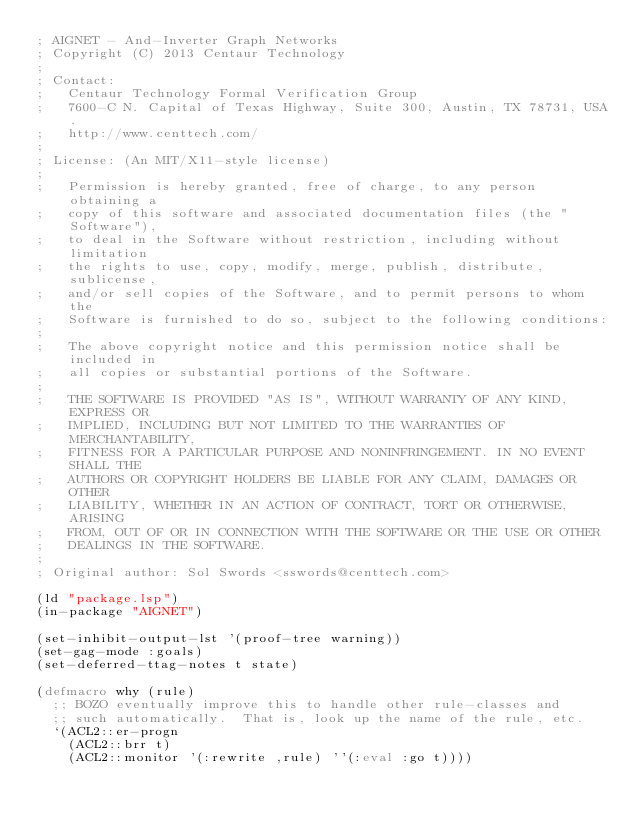<code> <loc_0><loc_0><loc_500><loc_500><_Lisp_>; AIGNET - And-Inverter Graph Networks
; Copyright (C) 2013 Centaur Technology
;
; Contact:
;   Centaur Technology Formal Verification Group
;   7600-C N. Capital of Texas Highway, Suite 300, Austin, TX 78731, USA.
;   http://www.centtech.com/
;
; License: (An MIT/X11-style license)
;
;   Permission is hereby granted, free of charge, to any person obtaining a
;   copy of this software and associated documentation files (the "Software"),
;   to deal in the Software without restriction, including without limitation
;   the rights to use, copy, modify, merge, publish, distribute, sublicense,
;   and/or sell copies of the Software, and to permit persons to whom the
;   Software is furnished to do so, subject to the following conditions:
;
;   The above copyright notice and this permission notice shall be included in
;   all copies or substantial portions of the Software.
;
;   THE SOFTWARE IS PROVIDED "AS IS", WITHOUT WARRANTY OF ANY KIND, EXPRESS OR
;   IMPLIED, INCLUDING BUT NOT LIMITED TO THE WARRANTIES OF MERCHANTABILITY,
;   FITNESS FOR A PARTICULAR PURPOSE AND NONINFRINGEMENT. IN NO EVENT SHALL THE
;   AUTHORS OR COPYRIGHT HOLDERS BE LIABLE FOR ANY CLAIM, DAMAGES OR OTHER
;   LIABILITY, WHETHER IN AN ACTION OF CONTRACT, TORT OR OTHERWISE, ARISING
;   FROM, OUT OF OR IN CONNECTION WITH THE SOFTWARE OR THE USE OR OTHER
;   DEALINGS IN THE SOFTWARE.
;
; Original author: Sol Swords <sswords@centtech.com>

(ld "package.lsp")
(in-package "AIGNET")

(set-inhibit-output-lst '(proof-tree warning))
(set-gag-mode :goals)
(set-deferred-ttag-notes t state)

(defmacro why (rule)
  ;; BOZO eventually improve this to handle other rule-classes and 
  ;; such automatically.  That is, look up the name of the rule, etc.
  `(ACL2::er-progn
    (ACL2::brr t)
    (ACL2::monitor '(:rewrite ,rule) ''(:eval :go t))))


</code> 